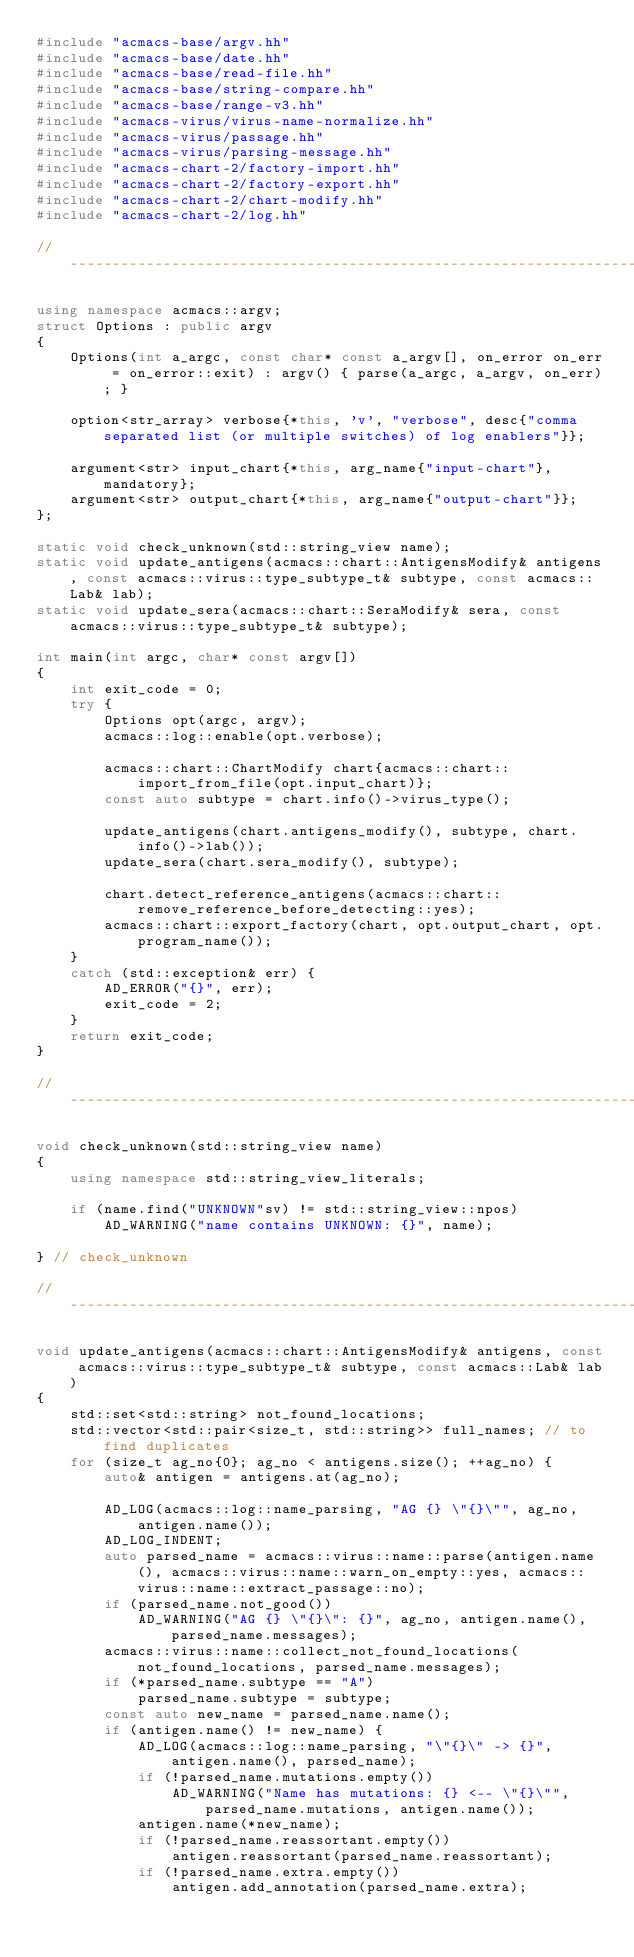<code> <loc_0><loc_0><loc_500><loc_500><_C++_>#include "acmacs-base/argv.hh"
#include "acmacs-base/date.hh"
#include "acmacs-base/read-file.hh"
#include "acmacs-base/string-compare.hh"
#include "acmacs-base/range-v3.hh"
#include "acmacs-virus/virus-name-normalize.hh"
#include "acmacs-virus/passage.hh"
#include "acmacs-virus/parsing-message.hh"
#include "acmacs-chart-2/factory-import.hh"
#include "acmacs-chart-2/factory-export.hh"
#include "acmacs-chart-2/chart-modify.hh"
#include "acmacs-chart-2/log.hh"

// ----------------------------------------------------------------------

using namespace acmacs::argv;
struct Options : public argv
{
    Options(int a_argc, const char* const a_argv[], on_error on_err = on_error::exit) : argv() { parse(a_argc, a_argv, on_err); }

    option<str_array> verbose{*this, 'v', "verbose", desc{"comma separated list (or multiple switches) of log enablers"}};

    argument<str> input_chart{*this, arg_name{"input-chart"}, mandatory};
    argument<str> output_chart{*this, arg_name{"output-chart"}};
};

static void check_unknown(std::string_view name);
static void update_antigens(acmacs::chart::AntigensModify& antigens, const acmacs::virus::type_subtype_t& subtype, const acmacs::Lab& lab);
static void update_sera(acmacs::chart::SeraModify& sera, const acmacs::virus::type_subtype_t& subtype);

int main(int argc, char* const argv[])
{
    int exit_code = 0;
    try {
        Options opt(argc, argv);
        acmacs::log::enable(opt.verbose);

        acmacs::chart::ChartModify chart{acmacs::chart::import_from_file(opt.input_chart)};
        const auto subtype = chart.info()->virus_type();

        update_antigens(chart.antigens_modify(), subtype, chart.info()->lab());
        update_sera(chart.sera_modify(), subtype);

        chart.detect_reference_antigens(acmacs::chart::remove_reference_before_detecting::yes);
        acmacs::chart::export_factory(chart, opt.output_chart, opt.program_name());
    }
    catch (std::exception& err) {
        AD_ERROR("{}", err);
        exit_code = 2;
    }
    return exit_code;
}

// ----------------------------------------------------------------------

void check_unknown(std::string_view name)
{
    using namespace std::string_view_literals;

    if (name.find("UNKNOWN"sv) != std::string_view::npos)
        AD_WARNING("name contains UNKNOWN: {}", name);

} // check_unknown

// ----------------------------------------------------------------------

void update_antigens(acmacs::chart::AntigensModify& antigens, const acmacs::virus::type_subtype_t& subtype, const acmacs::Lab& lab)
{
    std::set<std::string> not_found_locations;
    std::vector<std::pair<size_t, std::string>> full_names; // to find duplicates
    for (size_t ag_no{0}; ag_no < antigens.size(); ++ag_no) {
        auto& antigen = antigens.at(ag_no);

        AD_LOG(acmacs::log::name_parsing, "AG {} \"{}\"", ag_no, antigen.name());
        AD_LOG_INDENT;
        auto parsed_name = acmacs::virus::name::parse(antigen.name(), acmacs::virus::name::warn_on_empty::yes, acmacs::virus::name::extract_passage::no);
        if (parsed_name.not_good())
            AD_WARNING("AG {} \"{}\": {}", ag_no, antigen.name(), parsed_name.messages);
        acmacs::virus::name::collect_not_found_locations(not_found_locations, parsed_name.messages);
        if (*parsed_name.subtype == "A")
            parsed_name.subtype = subtype;
        const auto new_name = parsed_name.name();
        if (antigen.name() != new_name) {
            AD_LOG(acmacs::log::name_parsing, "\"{}\" -> {}", antigen.name(), parsed_name);
            if (!parsed_name.mutations.empty())
                AD_WARNING("Name has mutations: {} <-- \"{}\"", parsed_name.mutations, antigen.name());
            antigen.name(*new_name);
            if (!parsed_name.reassortant.empty())
                antigen.reassortant(parsed_name.reassortant);
            if (!parsed_name.extra.empty())
                antigen.add_annotation(parsed_name.extra);</code> 